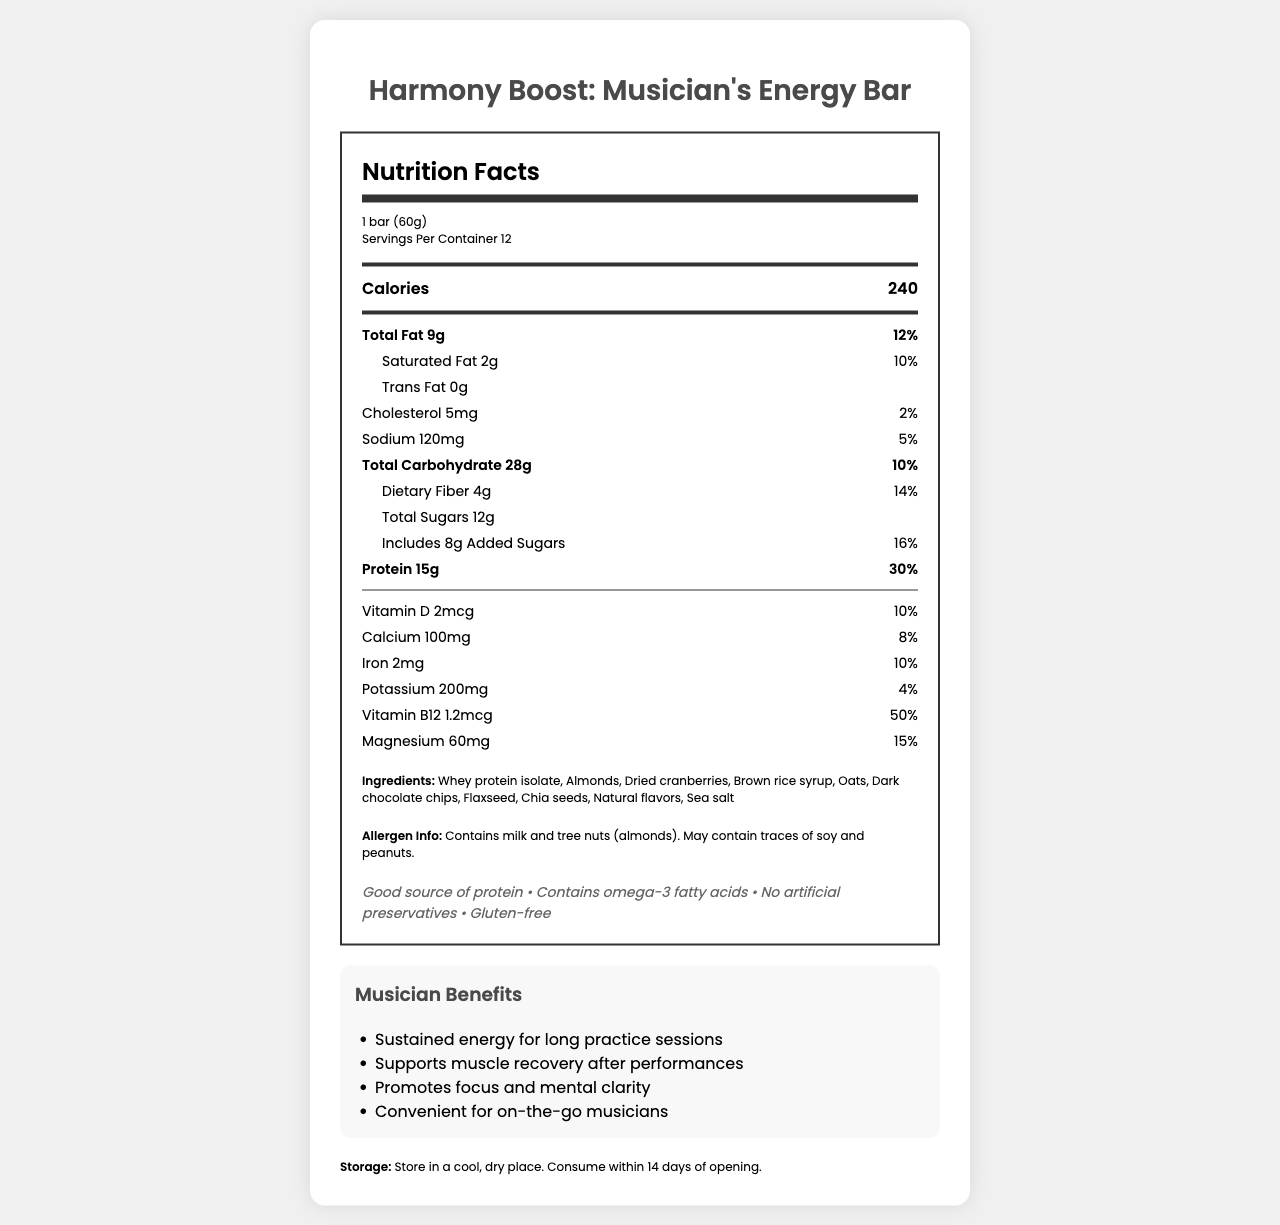what is the serving size? The serving size is clearly labeled as "1 bar (60g)" in the serving information section.
Answer: 1 bar (60g) how many servings are there per container? The document states "Servings Per Container 12" in the serving information section.
Answer: 12 how many calories are in one serving? The number of calories per serving is displayed prominently in the nutrition label as "Calories 240".
Answer: 240 what is the total fat content per serving? The total fat content per serving is listed as "Total Fat 9g" in the nutrition label.
Answer: 9g what allergens are present in this energy bar? The allergen information states "Contains milk and tree nuts (almonds). May contain traces of soy and peanuts."
Answer: Milk and tree nuts (almonds) what percentage of the daily value of vitamin B12 does one bar provide? The vitamin B12 information shows a daily value of 50%.
Answer: 50% what ingredients are included in the Harmony Boost energy bar? The document lists all the ingredients in the "Ingredients" section.
Answer: Whey protein isolate, Almonds, Dried cranberries, Brown rice syrup, Oats, Dark chocolate chips, Flaxseed, Chia seeds, Natural flavors, Sea salt how much protein is in one serving? The nutrition label shows that the energy bar contains 15g of protein per serving.
Answer: 15g What makes this energy bar beneficial for musicians? The "Musician Benefits" section explains that the bar provides sustained energy for long practice sessions, supports muscle recovery after performances, promotes focus and mental clarity, and is convenient for on-the-go musicians.
Answer: Sustained energy for long practice sessions what is the recommended storage method for this bar? The storage instructions recommend storing the bar in a cool, dry place and consuming it within 14 days of opening.
Answer: Store in a cool, dry place. Consume within 14 days of opening. The Harmony Boost energy bar is labeled as "gluten-free." True or False? One of the claims listed includes "Gluten-free."
Answer: True which nutrient provides the highest percentage of the daily value? A. Calcium B. Iron C. Vitamin B12 D. Magnesium The nutrition label shows that Vitamin B12 provides 50% of the daily value, which is the highest among the listed options.
Answer: C how many grams of dietary fiber are in one serving? A. 2g B. 3g C. 4g D. 5g The nutrition label states that there are 4g of dietary fiber per serving.
Answer: C Can we determine the cost of one energy bar from the document? The document does not provide any pricing information.
Answer: No Summarize the key features of the Harmony Boost: Musician's Energy Bar. The document provides detailed nutritional information, ingredients, allergen info, health claims, musician benefits, and storage instructions, highlighting its relevance to musicians’ dietary needs.
Answer: The Harmony Boost: Musician's Energy Bar is designed for musicians, offering a balance of protein and various nutrients to support energy, focus, and muscle recovery. It contains 240 calories per serving, with significant amounts of protein (15g) and dietary fiber (4g). It is gluten-free and includes ingredients like whey protein isolate, almonds, and dark chocolate chips. The bar supports sustained energy and is convenient for on-the-go use. 